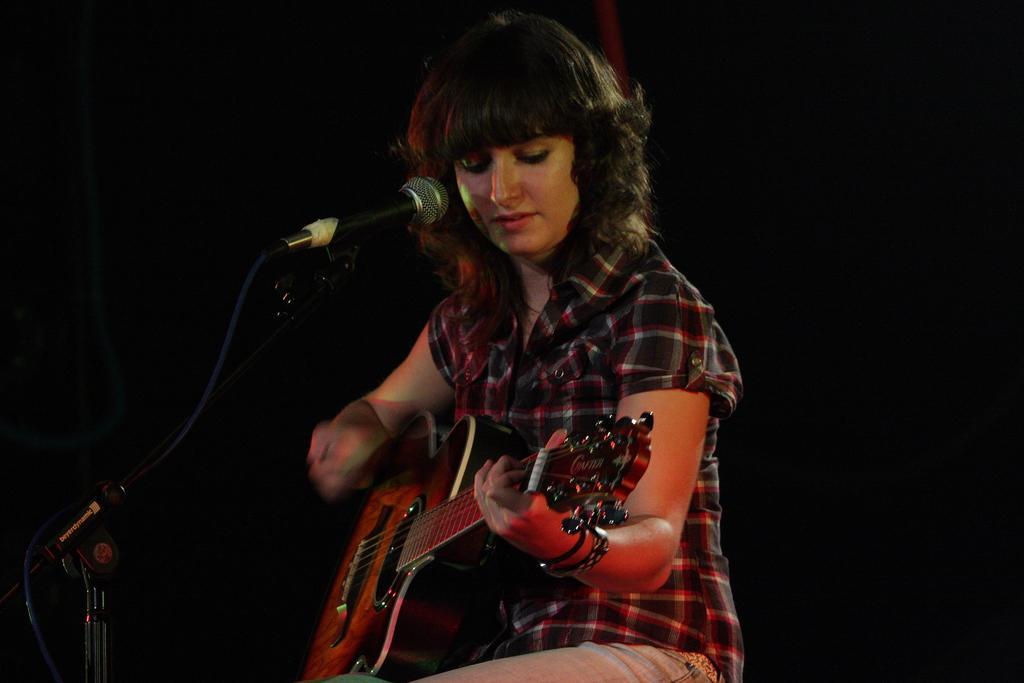How would you summarize this image in a sentence or two? This picture is a woman sitting and playing the guitar as a microphone in front of her. 